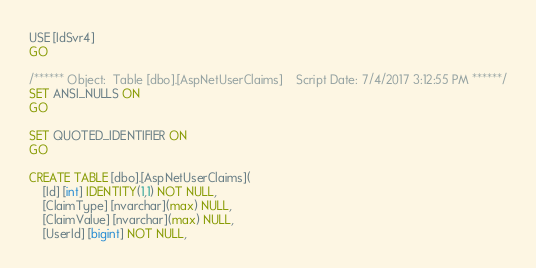<code> <loc_0><loc_0><loc_500><loc_500><_SQL_>USE [IdSvr4]
GO

/****** Object:  Table [dbo].[AspNetUserClaims]    Script Date: 7/4/2017 3:12:55 PM ******/
SET ANSI_NULLS ON
GO

SET QUOTED_IDENTIFIER ON
GO

CREATE TABLE [dbo].[AspNetUserClaims](
	[Id] [int] IDENTITY(1,1) NOT NULL,
	[ClaimType] [nvarchar](max) NULL,
	[ClaimValue] [nvarchar](max) NULL,
	[UserId] [bigint] NOT NULL,</code> 